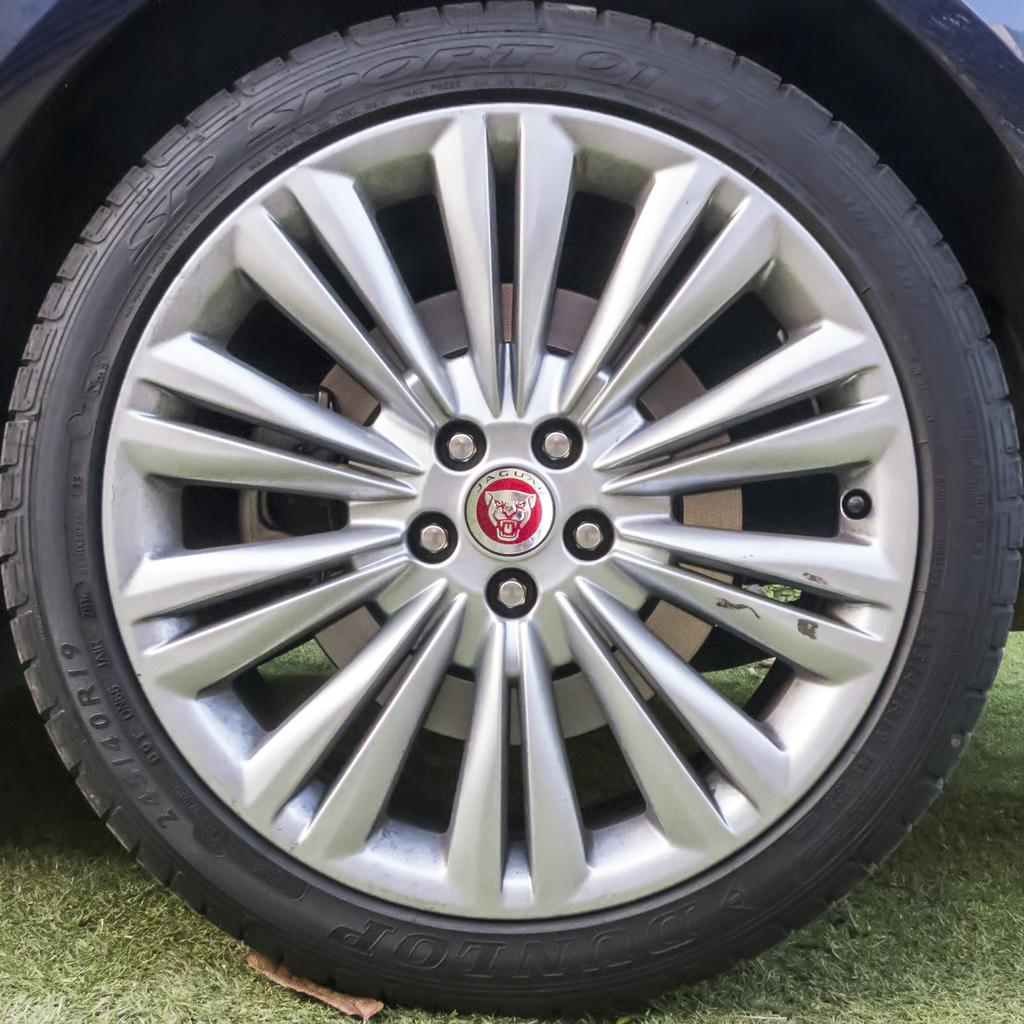What is the main subject of the picture? The main subject of the picture is a wheel of a vehicle. What type of surface is the wheel on? The wheel is on a grass surface. Can you see a wave of water in the picture? No, there is no wave of water present in the image. Is there a rifle visible in the picture? No, there is no rifle visible in the image. 